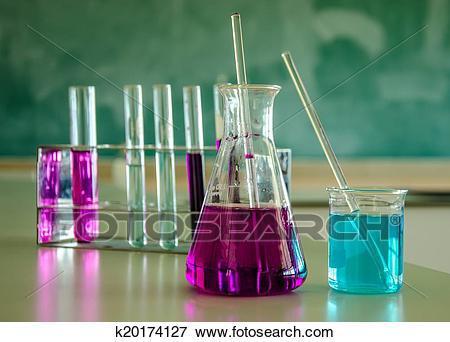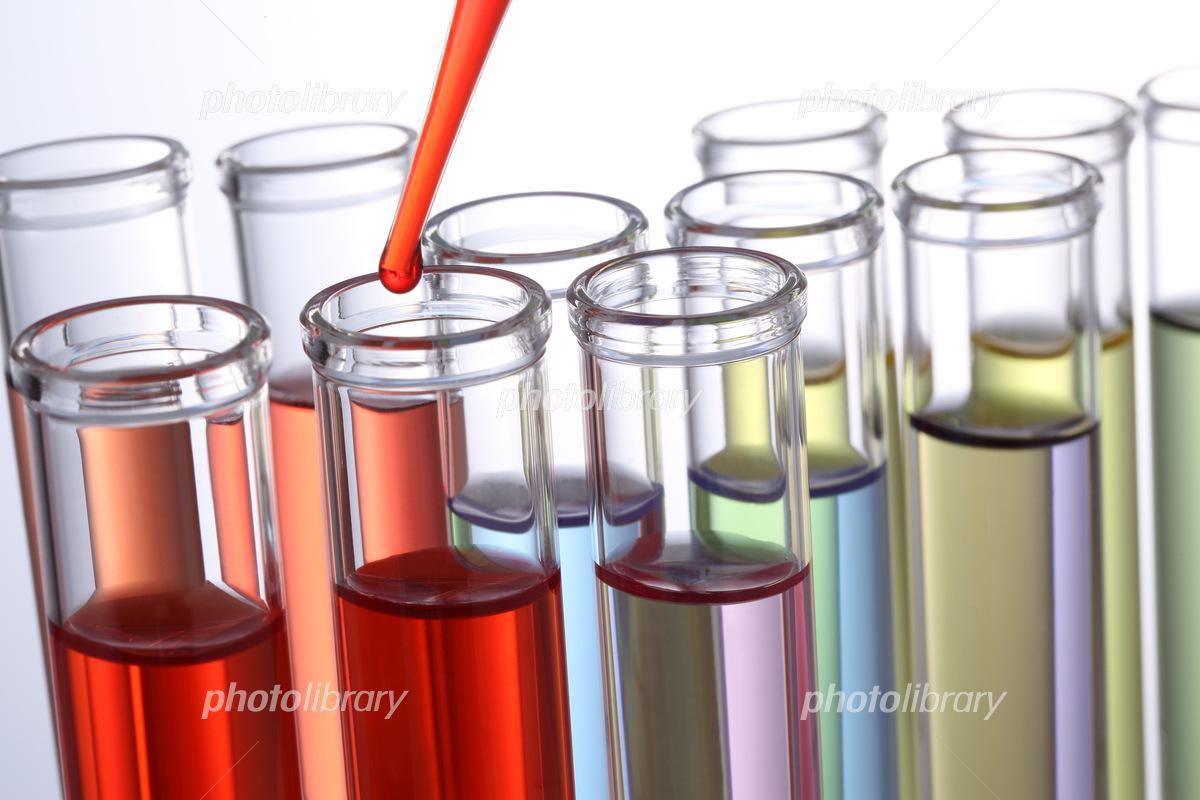The first image is the image on the left, the second image is the image on the right. For the images shown, is this caption "The containers in each of the images are all long and slender." true? Answer yes or no. No. The first image is the image on the left, the second image is the image on the right. Assess this claim about the two images: "The left image shows a beaker of purple liquid to the front and right of a stand containing test tubes, at least two with purple liquid in them.". Correct or not? Answer yes or no. Yes. 